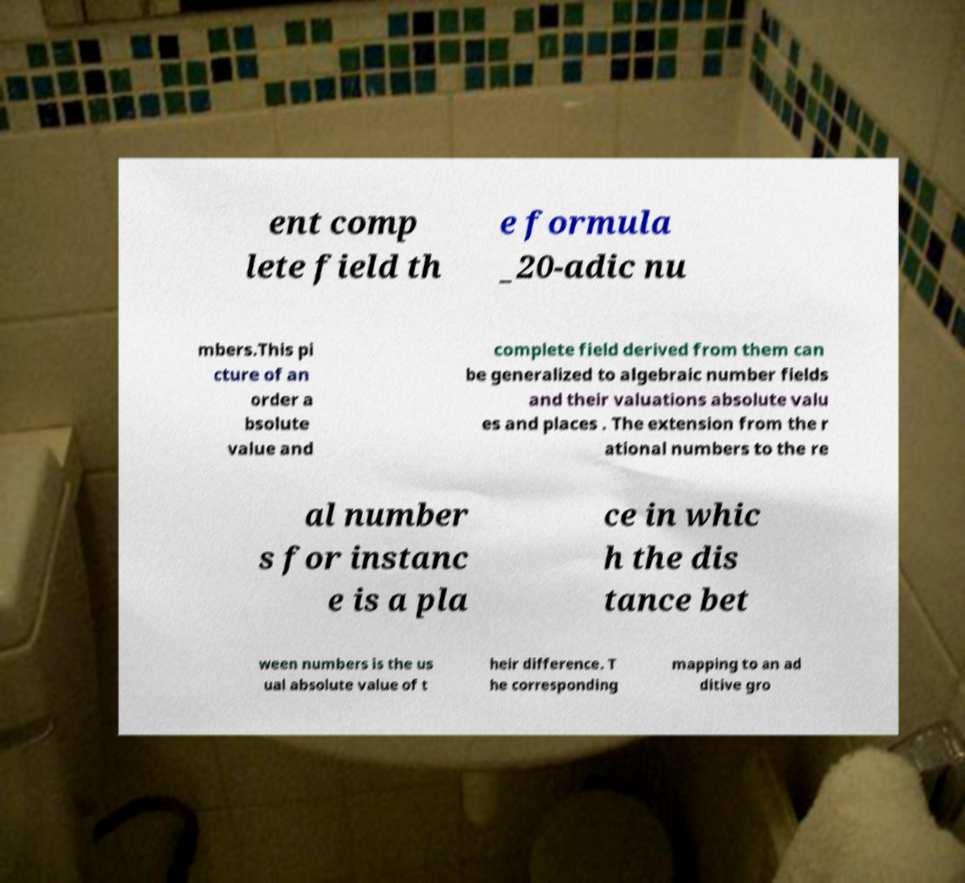Can you read and provide the text displayed in the image?This photo seems to have some interesting text. Can you extract and type it out for me? ent comp lete field th e formula _20-adic nu mbers.This pi cture of an order a bsolute value and complete field derived from them can be generalized to algebraic number fields and their valuations absolute valu es and places . The extension from the r ational numbers to the re al number s for instanc e is a pla ce in whic h the dis tance bet ween numbers is the us ual absolute value of t heir difference. T he corresponding mapping to an ad ditive gro 